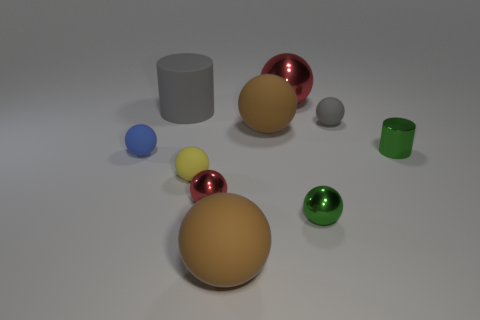Are there an equal number of big matte cylinders in front of the yellow thing and large green matte spheres?
Offer a terse response. Yes. Do the gray matte cylinder and the red shiny sphere that is in front of the big red sphere have the same size?
Ensure brevity in your answer.  No. What number of purple cubes have the same material as the tiny green ball?
Give a very brief answer. 0. Is the size of the green ball the same as the gray ball?
Your answer should be very brief. Yes. The tiny object that is to the right of the small red object and in front of the green cylinder has what shape?
Offer a terse response. Sphere. There is a red shiny sphere in front of the yellow matte thing; how big is it?
Keep it short and to the point. Small. How many big balls are right of the tiny green thing in front of the red sphere that is in front of the gray sphere?
Your response must be concise. 0. Are there any tiny spheres left of the small blue thing?
Your response must be concise. No. What number of other objects are the same size as the rubber cylinder?
Offer a very short reply. 3. The tiny ball that is both right of the small red thing and in front of the blue ball is made of what material?
Keep it short and to the point. Metal. 